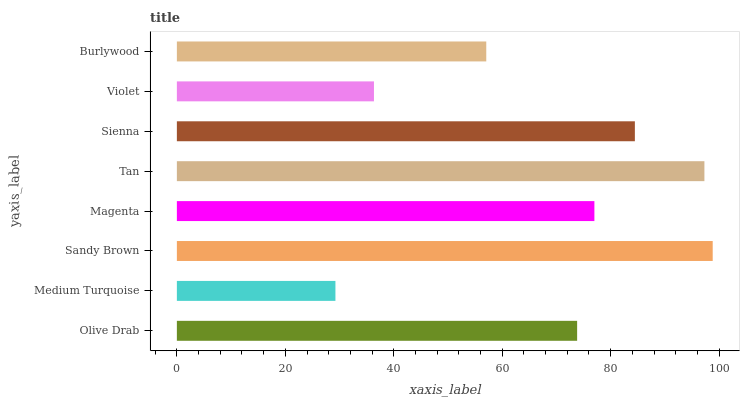Is Medium Turquoise the minimum?
Answer yes or no. Yes. Is Sandy Brown the maximum?
Answer yes or no. Yes. Is Sandy Brown the minimum?
Answer yes or no. No. Is Medium Turquoise the maximum?
Answer yes or no. No. Is Sandy Brown greater than Medium Turquoise?
Answer yes or no. Yes. Is Medium Turquoise less than Sandy Brown?
Answer yes or no. Yes. Is Medium Turquoise greater than Sandy Brown?
Answer yes or no. No. Is Sandy Brown less than Medium Turquoise?
Answer yes or no. No. Is Magenta the high median?
Answer yes or no. Yes. Is Olive Drab the low median?
Answer yes or no. Yes. Is Medium Turquoise the high median?
Answer yes or no. No. Is Burlywood the low median?
Answer yes or no. No. 